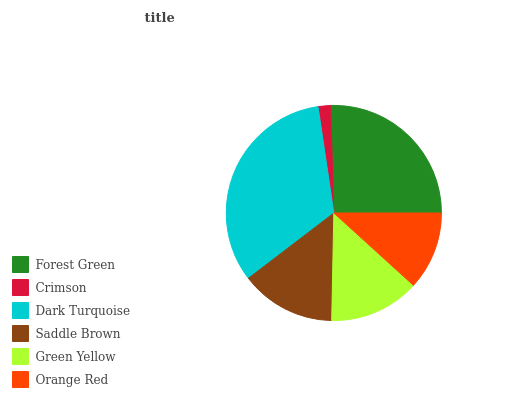Is Crimson the minimum?
Answer yes or no. Yes. Is Dark Turquoise the maximum?
Answer yes or no. Yes. Is Dark Turquoise the minimum?
Answer yes or no. No. Is Crimson the maximum?
Answer yes or no. No. Is Dark Turquoise greater than Crimson?
Answer yes or no. Yes. Is Crimson less than Dark Turquoise?
Answer yes or no. Yes. Is Crimson greater than Dark Turquoise?
Answer yes or no. No. Is Dark Turquoise less than Crimson?
Answer yes or no. No. Is Saddle Brown the high median?
Answer yes or no. Yes. Is Green Yellow the low median?
Answer yes or no. Yes. Is Crimson the high median?
Answer yes or no. No. Is Orange Red the low median?
Answer yes or no. No. 